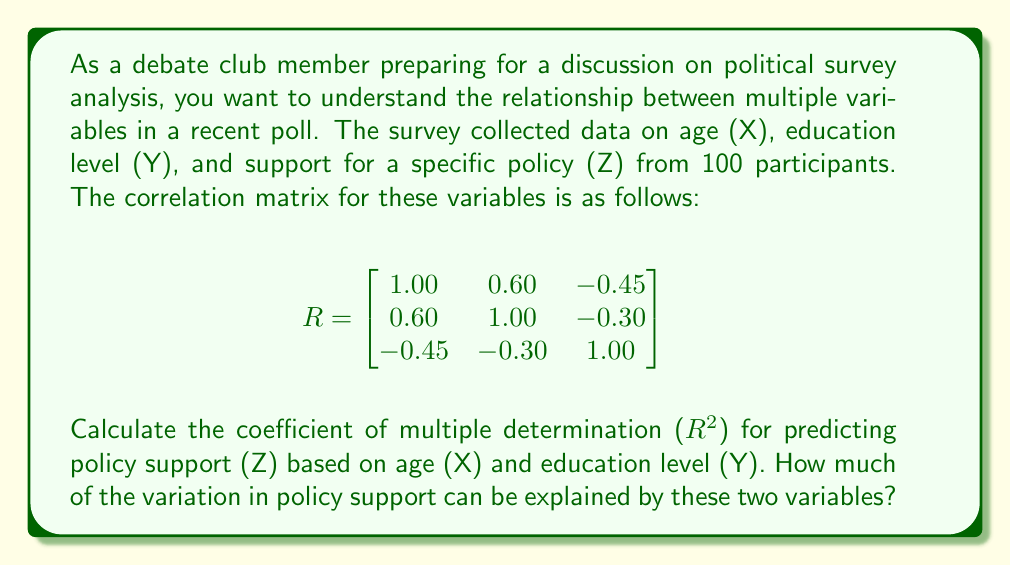Can you solve this math problem? To solve this problem, we'll follow these steps:

1. Identify the relevant correlations from the matrix:
   $r_{XZ} = -0.45$
   $r_{YZ} = -0.30$
   $r_{XY} = 0.60$

2. The coefficient of multiple determination ($R^2$) for predicting Z based on X and Y is given by the formula:

   $$R^2 = \frac{r_{XZ}^2 + r_{YZ}^2 - 2r_{XZ}r_{YZ}r_{XY}}{1 - r_{XY}^2}$$

3. Substitute the values into the formula:

   $$R^2 = \frac{(-0.45)^2 + (-0.30)^2 - 2(-0.45)(-0.30)(0.60)}{1 - (0.60)^2}$$

4. Calculate the numerator:
   $(-0.45)^2 = 0.2025$
   $(-0.30)^2 = 0.0900$
   $2(-0.45)(-0.30)(0.60) = 0.1620$
   
   Numerator $= 0.2025 + 0.0900 - 0.1620 = 0.1305$

5. Calculate the denominator:
   $1 - (0.60)^2 = 1 - 0.36 = 0.64$

6. Divide the numerator by the denominator:

   $$R^2 = \frac{0.1305}{0.64} = 0.2039$$

7. Convert to a percentage:
   $0.2039 \times 100 = 20.39\%$

Thus, approximately 20.39% of the variation in policy support can be explained by age and education level.
Answer: $R^2 = 0.2039$ or 20.39% 